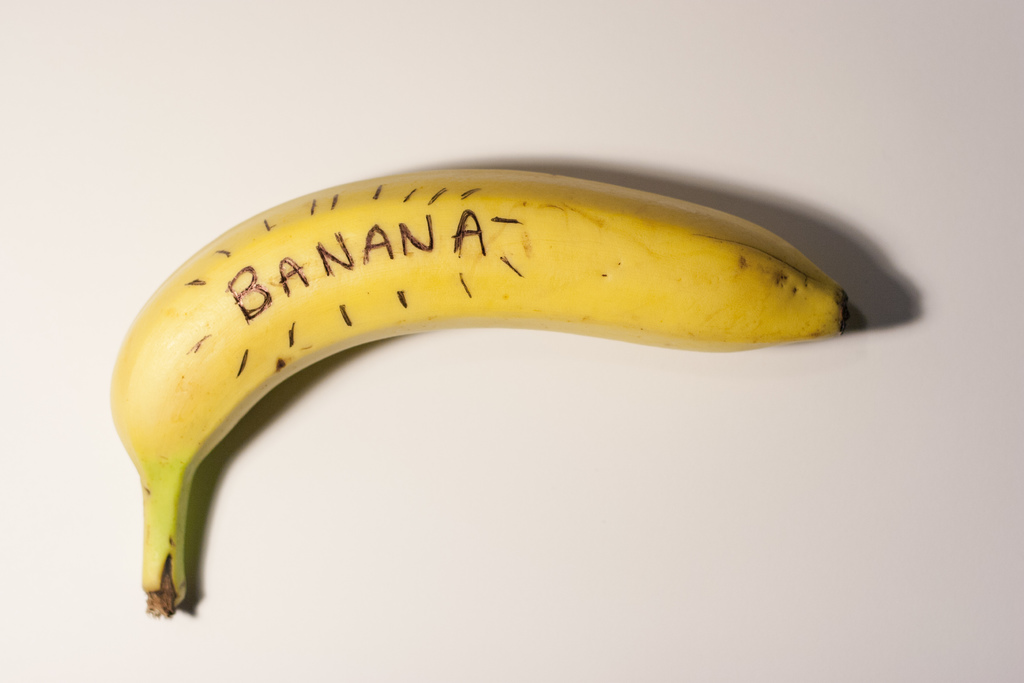What does the background tell us about the setting or intention behind the photograph? The plain white background of the image serves to focus the viewer's attention solely on the banana, enhancing its visual impact without any distractions. This minimalist approach suggests a controlled setting, likely chosen to emphasize the artistry or peculiar nature of the banana’s labeling. The background acts as a blank canvas, making the banana, and particularly the text on it, the central element of visual interest. 